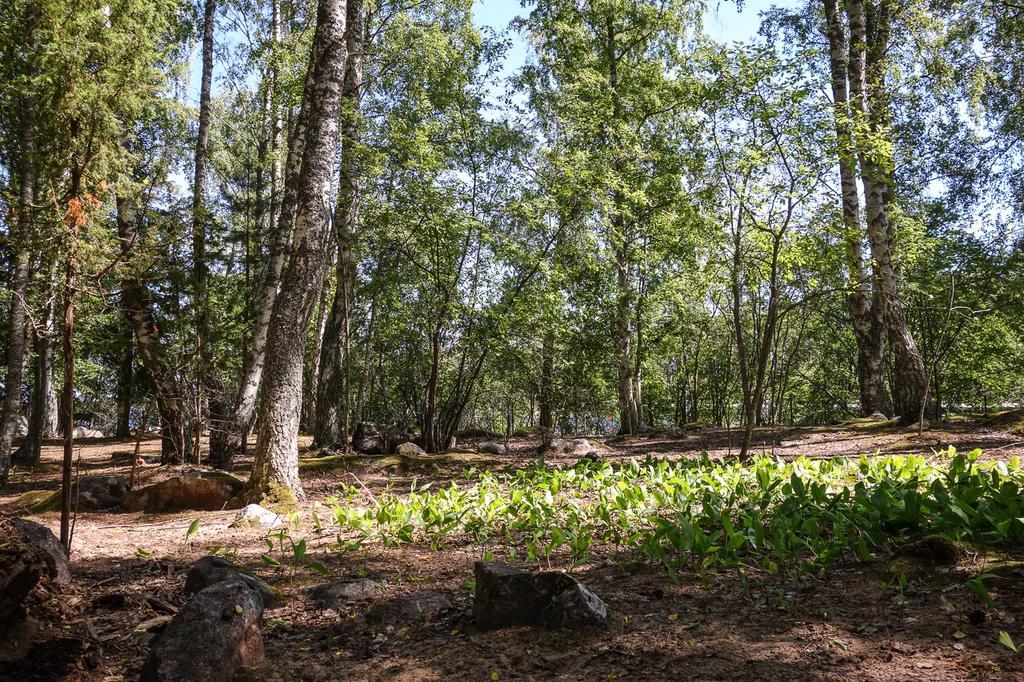Describe this image in one or two sentences. In the center of the image there are many trees. At the bottom we can see small plants and rocks. In the background there is a sky. 